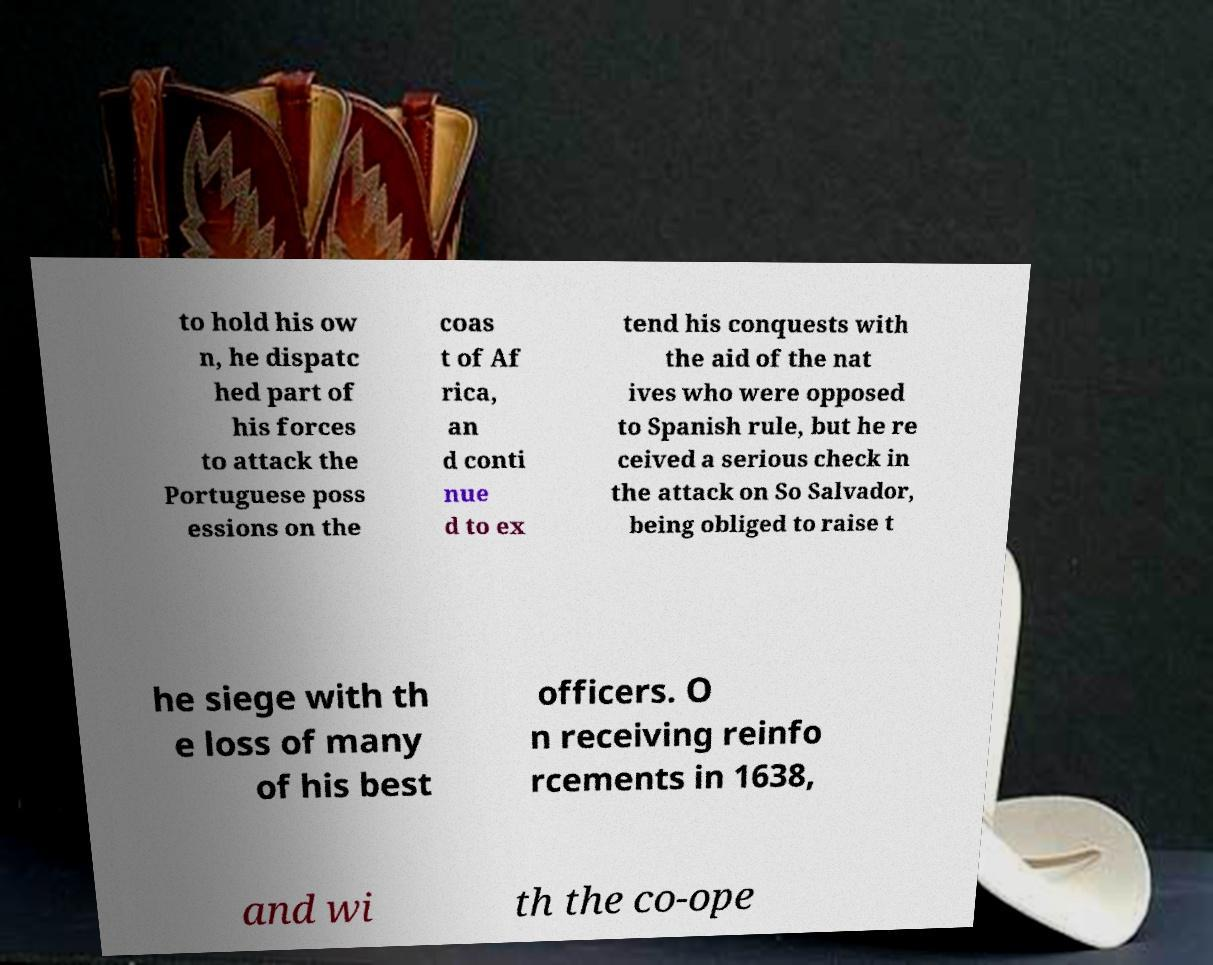Could you assist in decoding the text presented in this image and type it out clearly? to hold his ow n, he dispatc hed part of his forces to attack the Portuguese poss essions on the coas t of Af rica, an d conti nue d to ex tend his conquests with the aid of the nat ives who were opposed to Spanish rule, but he re ceived a serious check in the attack on So Salvador, being obliged to raise t he siege with th e loss of many of his best officers. O n receiving reinfo rcements in 1638, and wi th the co-ope 